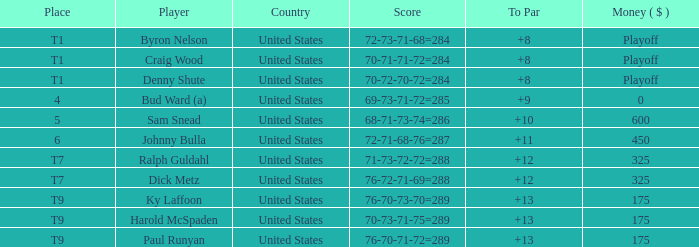What was the total to par achieved by craig wood? 8.0. 